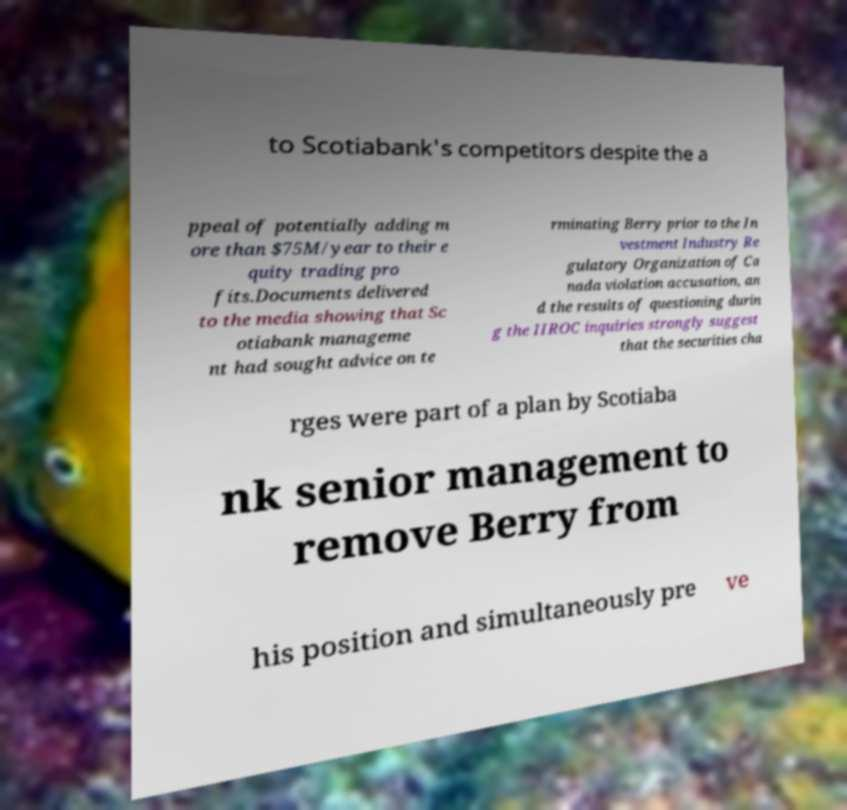Can you read and provide the text displayed in the image?This photo seems to have some interesting text. Can you extract and type it out for me? to Scotiabank's competitors despite the a ppeal of potentially adding m ore than $75M/year to their e quity trading pro fits.Documents delivered to the media showing that Sc otiabank manageme nt had sought advice on te rminating Berry prior to the In vestment Industry Re gulatory Organization of Ca nada violation accusation, an d the results of questioning durin g the IIROC inquiries strongly suggest that the securities cha rges were part of a plan by Scotiaba nk senior management to remove Berry from his position and simultaneously pre ve 